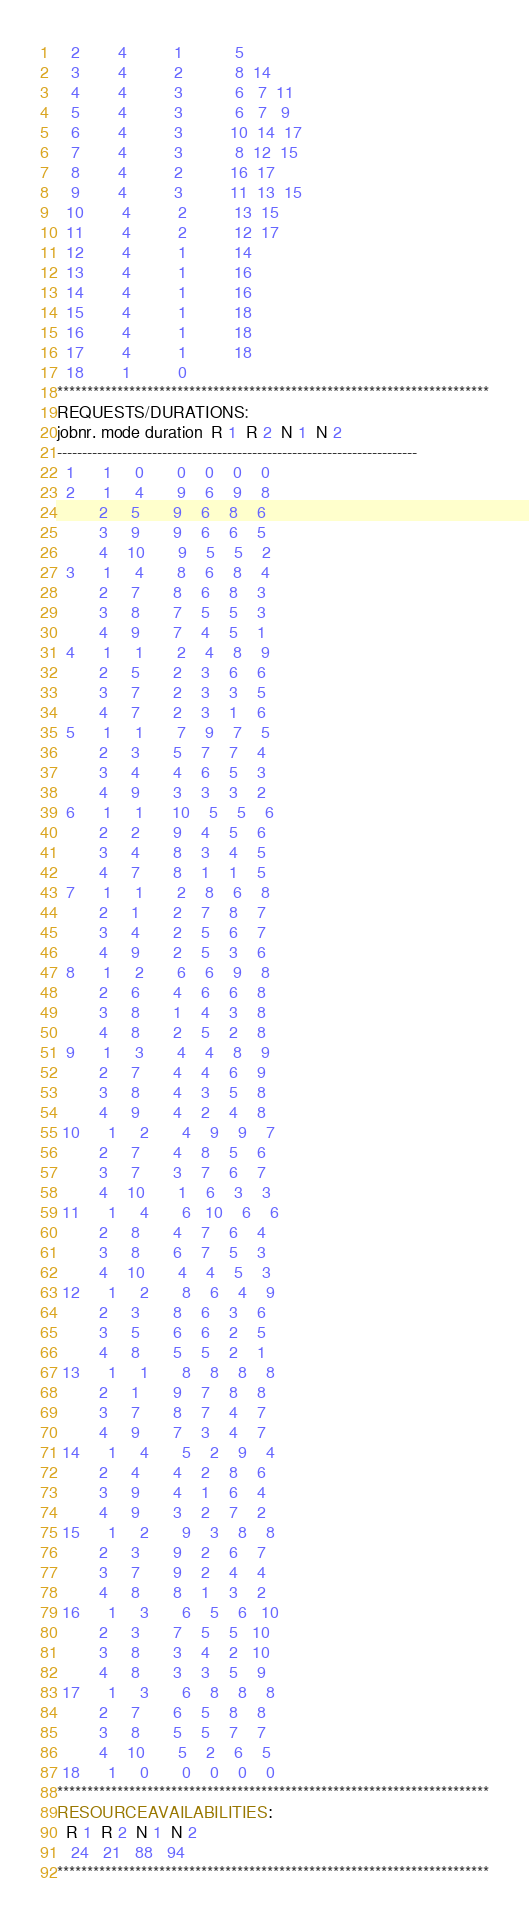<code> <loc_0><loc_0><loc_500><loc_500><_ObjectiveC_>   2        4          1           5
   3        4          2           8  14
   4        4          3           6   7  11
   5        4          3           6   7   9
   6        4          3          10  14  17
   7        4          3           8  12  15
   8        4          2          16  17
   9        4          3          11  13  15
  10        4          2          13  15
  11        4          2          12  17
  12        4          1          14
  13        4          1          16
  14        4          1          16
  15        4          1          18
  16        4          1          18
  17        4          1          18
  18        1          0        
************************************************************************
REQUESTS/DURATIONS:
jobnr. mode duration  R 1  R 2  N 1  N 2
------------------------------------------------------------------------
  1      1     0       0    0    0    0
  2      1     4       9    6    9    8
         2     5       9    6    8    6
         3     9       9    6    6    5
         4    10       9    5    5    2
  3      1     4       8    6    8    4
         2     7       8    6    8    3
         3     8       7    5    5    3
         4     9       7    4    5    1
  4      1     1       2    4    8    9
         2     5       2    3    6    6
         3     7       2    3    3    5
         4     7       2    3    1    6
  5      1     1       7    9    7    5
         2     3       5    7    7    4
         3     4       4    6    5    3
         4     9       3    3    3    2
  6      1     1      10    5    5    6
         2     2       9    4    5    6
         3     4       8    3    4    5
         4     7       8    1    1    5
  7      1     1       2    8    6    8
         2     1       2    7    8    7
         3     4       2    5    6    7
         4     9       2    5    3    6
  8      1     2       6    6    9    8
         2     6       4    6    6    8
         3     8       1    4    3    8
         4     8       2    5    2    8
  9      1     3       4    4    8    9
         2     7       4    4    6    9
         3     8       4    3    5    8
         4     9       4    2    4    8
 10      1     2       4    9    9    7
         2     7       4    8    5    6
         3     7       3    7    6    7
         4    10       1    6    3    3
 11      1     4       6   10    6    6
         2     8       4    7    6    4
         3     8       6    7    5    3
         4    10       4    4    5    3
 12      1     2       8    6    4    9
         2     3       8    6    3    6
         3     5       6    6    2    5
         4     8       5    5    2    1
 13      1     1       8    8    8    8
         2     1       9    7    8    8
         3     7       8    7    4    7
         4     9       7    3    4    7
 14      1     4       5    2    9    4
         2     4       4    2    8    6
         3     9       4    1    6    4
         4     9       3    2    7    2
 15      1     2       9    3    8    8
         2     3       9    2    6    7
         3     7       9    2    4    4
         4     8       8    1    3    2
 16      1     3       6    5    6   10
         2     3       7    5    5   10
         3     8       3    4    2   10
         4     8       3    3    5    9
 17      1     3       6    8    8    8
         2     7       6    5    8    8
         3     8       5    5    7    7
         4    10       5    2    6    5
 18      1     0       0    0    0    0
************************************************************************
RESOURCEAVAILABILITIES:
  R 1  R 2  N 1  N 2
   24   21   88   94
************************************************************************
</code> 